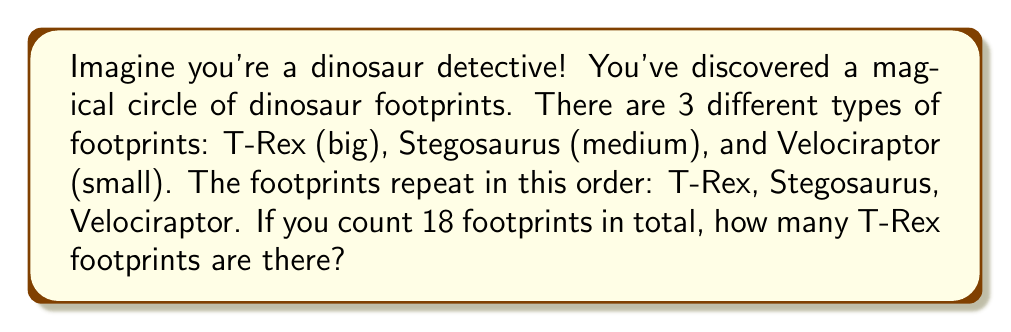Solve this math problem. Let's solve this dinosaur mystery step by step:

1. We know there are 3 types of footprints that repeat in a pattern:
   T-Rex → Stegosaurus → Velociraptor

2. This means every 3 footprints, we see 1 T-Rex footprint.

3. We can use division to find out how many complete sets of 3 footprints are in our circle:
   $$ \text{Number of complete sets} = \frac{\text{Total footprints}}{\text{Footprints in each set}} = \frac{18}{3} = 6 $$

4. Since there is 1 T-Rex footprint in each set, and we have 6 complete sets, we can conclude:
   $$ \text{Number of T-Rex footprints} = 6 $$

5. We can double-check our answer:
   - 6 T-Rex footprints
   - 6 Stegosaurus footprints
   - 6 Velociraptor footprints
   $$ 6 + 6 + 6 = 18 \text{ (total footprints)} $$

So, our detective work shows that there are 6 T-Rex footprints in the magical circle!
Answer: 6 T-Rex footprints 